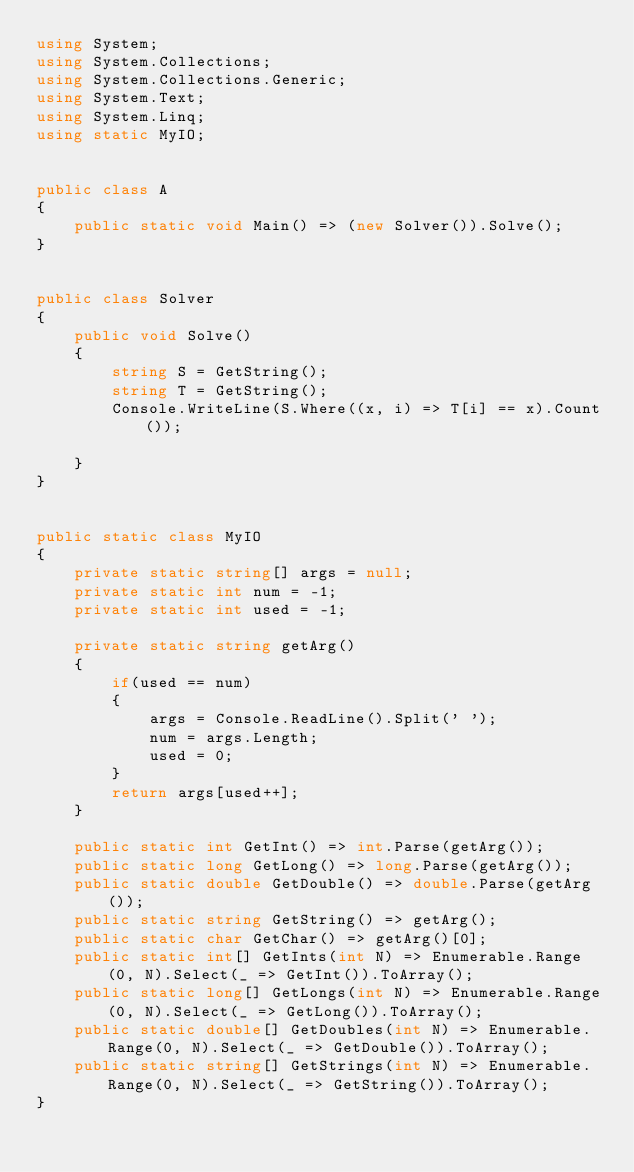<code> <loc_0><loc_0><loc_500><loc_500><_C#_>using System;
using System.Collections;
using System.Collections.Generic;
using System.Text;
using System.Linq;
using static MyIO;


public class A
{
	public static void Main() => (new Solver()).Solve();
}


public class Solver
{
	public void Solve()
	{
		string S = GetString();
		string T = GetString();
		Console.WriteLine(S.Where((x, i) => T[i] == x).Count());

	}
}


public static class MyIO
{
	private static string[] args = null;
	private static int num = -1;
	private static int used = -1;

	private static string getArg()
	{
		if(used == num)
		{
			args = Console.ReadLine().Split(' ');
			num = args.Length;
			used = 0;
		}
		return args[used++];
	}

	public static int GetInt() => int.Parse(getArg());
	public static long GetLong() => long.Parse(getArg());
	public static double GetDouble() => double.Parse(getArg());
	public static string GetString() => getArg();
	public static char GetChar() => getArg()[0];
	public static int[] GetInts(int N) => Enumerable.Range(0, N).Select(_ => GetInt()).ToArray();
	public static long[] GetLongs(int N) => Enumerable.Range(0, N).Select(_ => GetLong()).ToArray();
	public static double[] GetDoubles(int N) => Enumerable.Range(0, N).Select(_ => GetDouble()).ToArray();
	public static string[] GetStrings(int N) => Enumerable.Range(0, N).Select(_ => GetString()).ToArray();
}
</code> 